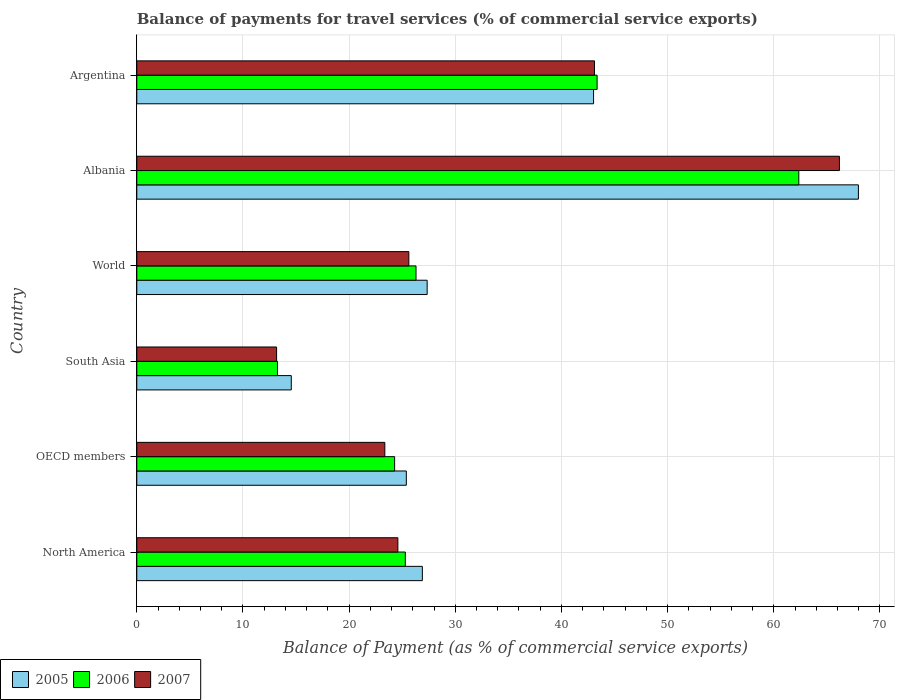Are the number of bars on each tick of the Y-axis equal?
Your response must be concise. Yes. How many bars are there on the 5th tick from the top?
Ensure brevity in your answer.  3. How many bars are there on the 6th tick from the bottom?
Provide a short and direct response. 3. What is the balance of payments for travel services in 2005 in OECD members?
Offer a terse response. 25.39. Across all countries, what is the maximum balance of payments for travel services in 2005?
Offer a very short reply. 67.97. Across all countries, what is the minimum balance of payments for travel services in 2007?
Offer a very short reply. 13.17. In which country was the balance of payments for travel services in 2007 maximum?
Keep it short and to the point. Albania. In which country was the balance of payments for travel services in 2006 minimum?
Give a very brief answer. South Asia. What is the total balance of payments for travel services in 2006 in the graph?
Your response must be concise. 194.85. What is the difference between the balance of payments for travel services in 2006 in South Asia and that in World?
Provide a short and direct response. -13.05. What is the difference between the balance of payments for travel services in 2006 in Argentina and the balance of payments for travel services in 2005 in Albania?
Give a very brief answer. -24.62. What is the average balance of payments for travel services in 2007 per country?
Offer a very short reply. 32.67. What is the difference between the balance of payments for travel services in 2006 and balance of payments for travel services in 2007 in OECD members?
Give a very brief answer. 0.92. What is the ratio of the balance of payments for travel services in 2005 in North America to that in OECD members?
Your response must be concise. 1.06. Is the difference between the balance of payments for travel services in 2006 in Albania and OECD members greater than the difference between the balance of payments for travel services in 2007 in Albania and OECD members?
Make the answer very short. No. What is the difference between the highest and the second highest balance of payments for travel services in 2005?
Ensure brevity in your answer.  24.95. What is the difference between the highest and the lowest balance of payments for travel services in 2007?
Offer a very short reply. 53.02. In how many countries, is the balance of payments for travel services in 2005 greater than the average balance of payments for travel services in 2005 taken over all countries?
Give a very brief answer. 2. Is the sum of the balance of payments for travel services in 2006 in Argentina and South Asia greater than the maximum balance of payments for travel services in 2005 across all countries?
Offer a very short reply. No. What does the 2nd bar from the bottom in Argentina represents?
Offer a very short reply. 2006. Is it the case that in every country, the sum of the balance of payments for travel services in 2006 and balance of payments for travel services in 2005 is greater than the balance of payments for travel services in 2007?
Provide a succinct answer. Yes. What is the difference between two consecutive major ticks on the X-axis?
Give a very brief answer. 10. Are the values on the major ticks of X-axis written in scientific E-notation?
Your answer should be very brief. No. Does the graph contain any zero values?
Offer a terse response. No. Where does the legend appear in the graph?
Provide a succinct answer. Bottom left. How many legend labels are there?
Your answer should be compact. 3. What is the title of the graph?
Offer a very short reply. Balance of payments for travel services (% of commercial service exports). What is the label or title of the X-axis?
Ensure brevity in your answer.  Balance of Payment (as % of commercial service exports). What is the label or title of the Y-axis?
Provide a short and direct response. Country. What is the Balance of Payment (as % of commercial service exports) of 2005 in North America?
Your answer should be compact. 26.9. What is the Balance of Payment (as % of commercial service exports) in 2006 in North America?
Provide a short and direct response. 25.3. What is the Balance of Payment (as % of commercial service exports) of 2007 in North America?
Your response must be concise. 24.59. What is the Balance of Payment (as % of commercial service exports) in 2005 in OECD members?
Keep it short and to the point. 25.39. What is the Balance of Payment (as % of commercial service exports) of 2006 in OECD members?
Your response must be concise. 24.29. What is the Balance of Payment (as % of commercial service exports) of 2007 in OECD members?
Your response must be concise. 23.36. What is the Balance of Payment (as % of commercial service exports) in 2005 in South Asia?
Offer a very short reply. 14.55. What is the Balance of Payment (as % of commercial service exports) of 2006 in South Asia?
Provide a short and direct response. 13.25. What is the Balance of Payment (as % of commercial service exports) of 2007 in South Asia?
Provide a short and direct response. 13.17. What is the Balance of Payment (as % of commercial service exports) in 2005 in World?
Your answer should be compact. 27.35. What is the Balance of Payment (as % of commercial service exports) of 2006 in World?
Make the answer very short. 26.3. What is the Balance of Payment (as % of commercial service exports) in 2007 in World?
Make the answer very short. 25.63. What is the Balance of Payment (as % of commercial service exports) in 2005 in Albania?
Your response must be concise. 67.97. What is the Balance of Payment (as % of commercial service exports) of 2006 in Albania?
Make the answer very short. 62.36. What is the Balance of Payment (as % of commercial service exports) in 2007 in Albania?
Provide a short and direct response. 66.18. What is the Balance of Payment (as % of commercial service exports) in 2005 in Argentina?
Provide a short and direct response. 43.03. What is the Balance of Payment (as % of commercial service exports) in 2006 in Argentina?
Ensure brevity in your answer.  43.36. What is the Balance of Payment (as % of commercial service exports) in 2007 in Argentina?
Offer a very short reply. 43.11. Across all countries, what is the maximum Balance of Payment (as % of commercial service exports) in 2005?
Provide a succinct answer. 67.97. Across all countries, what is the maximum Balance of Payment (as % of commercial service exports) in 2006?
Ensure brevity in your answer.  62.36. Across all countries, what is the maximum Balance of Payment (as % of commercial service exports) in 2007?
Your answer should be very brief. 66.18. Across all countries, what is the minimum Balance of Payment (as % of commercial service exports) in 2005?
Ensure brevity in your answer.  14.55. Across all countries, what is the minimum Balance of Payment (as % of commercial service exports) in 2006?
Provide a short and direct response. 13.25. Across all countries, what is the minimum Balance of Payment (as % of commercial service exports) of 2007?
Your answer should be compact. 13.17. What is the total Balance of Payment (as % of commercial service exports) in 2005 in the graph?
Give a very brief answer. 205.19. What is the total Balance of Payment (as % of commercial service exports) of 2006 in the graph?
Keep it short and to the point. 194.85. What is the total Balance of Payment (as % of commercial service exports) in 2007 in the graph?
Offer a very short reply. 196.05. What is the difference between the Balance of Payment (as % of commercial service exports) of 2005 in North America and that in OECD members?
Your answer should be compact. 1.51. What is the difference between the Balance of Payment (as % of commercial service exports) in 2006 in North America and that in OECD members?
Ensure brevity in your answer.  1.01. What is the difference between the Balance of Payment (as % of commercial service exports) of 2007 in North America and that in OECD members?
Give a very brief answer. 1.23. What is the difference between the Balance of Payment (as % of commercial service exports) in 2005 in North America and that in South Asia?
Your response must be concise. 12.35. What is the difference between the Balance of Payment (as % of commercial service exports) of 2006 in North America and that in South Asia?
Offer a very short reply. 12.04. What is the difference between the Balance of Payment (as % of commercial service exports) of 2007 in North America and that in South Asia?
Your answer should be compact. 11.42. What is the difference between the Balance of Payment (as % of commercial service exports) in 2005 in North America and that in World?
Provide a short and direct response. -0.45. What is the difference between the Balance of Payment (as % of commercial service exports) of 2006 in North America and that in World?
Provide a short and direct response. -1.01. What is the difference between the Balance of Payment (as % of commercial service exports) in 2007 in North America and that in World?
Your response must be concise. -1.04. What is the difference between the Balance of Payment (as % of commercial service exports) in 2005 in North America and that in Albania?
Provide a succinct answer. -41.07. What is the difference between the Balance of Payment (as % of commercial service exports) of 2006 in North America and that in Albania?
Your answer should be compact. -37.06. What is the difference between the Balance of Payment (as % of commercial service exports) in 2007 in North America and that in Albania?
Make the answer very short. -41.59. What is the difference between the Balance of Payment (as % of commercial service exports) in 2005 in North America and that in Argentina?
Make the answer very short. -16.13. What is the difference between the Balance of Payment (as % of commercial service exports) of 2006 in North America and that in Argentina?
Give a very brief answer. -18.06. What is the difference between the Balance of Payment (as % of commercial service exports) in 2007 in North America and that in Argentina?
Provide a short and direct response. -18.52. What is the difference between the Balance of Payment (as % of commercial service exports) in 2005 in OECD members and that in South Asia?
Your answer should be compact. 10.84. What is the difference between the Balance of Payment (as % of commercial service exports) of 2006 in OECD members and that in South Asia?
Offer a very short reply. 11.04. What is the difference between the Balance of Payment (as % of commercial service exports) of 2007 in OECD members and that in South Asia?
Keep it short and to the point. 10.2. What is the difference between the Balance of Payment (as % of commercial service exports) of 2005 in OECD members and that in World?
Provide a succinct answer. -1.96. What is the difference between the Balance of Payment (as % of commercial service exports) in 2006 in OECD members and that in World?
Make the answer very short. -2.01. What is the difference between the Balance of Payment (as % of commercial service exports) of 2007 in OECD members and that in World?
Your answer should be compact. -2.26. What is the difference between the Balance of Payment (as % of commercial service exports) of 2005 in OECD members and that in Albania?
Keep it short and to the point. -42.58. What is the difference between the Balance of Payment (as % of commercial service exports) in 2006 in OECD members and that in Albania?
Give a very brief answer. -38.07. What is the difference between the Balance of Payment (as % of commercial service exports) of 2007 in OECD members and that in Albania?
Your answer should be very brief. -42.82. What is the difference between the Balance of Payment (as % of commercial service exports) of 2005 in OECD members and that in Argentina?
Provide a short and direct response. -17.64. What is the difference between the Balance of Payment (as % of commercial service exports) of 2006 in OECD members and that in Argentina?
Your response must be concise. -19.07. What is the difference between the Balance of Payment (as % of commercial service exports) of 2007 in OECD members and that in Argentina?
Your answer should be compact. -19.75. What is the difference between the Balance of Payment (as % of commercial service exports) of 2005 in South Asia and that in World?
Your response must be concise. -12.8. What is the difference between the Balance of Payment (as % of commercial service exports) of 2006 in South Asia and that in World?
Offer a very short reply. -13.05. What is the difference between the Balance of Payment (as % of commercial service exports) in 2007 in South Asia and that in World?
Your answer should be compact. -12.46. What is the difference between the Balance of Payment (as % of commercial service exports) of 2005 in South Asia and that in Albania?
Your answer should be compact. -53.42. What is the difference between the Balance of Payment (as % of commercial service exports) in 2006 in South Asia and that in Albania?
Offer a terse response. -49.11. What is the difference between the Balance of Payment (as % of commercial service exports) in 2007 in South Asia and that in Albania?
Ensure brevity in your answer.  -53.02. What is the difference between the Balance of Payment (as % of commercial service exports) in 2005 in South Asia and that in Argentina?
Your answer should be compact. -28.47. What is the difference between the Balance of Payment (as % of commercial service exports) in 2006 in South Asia and that in Argentina?
Provide a succinct answer. -30.11. What is the difference between the Balance of Payment (as % of commercial service exports) in 2007 in South Asia and that in Argentina?
Your answer should be compact. -29.94. What is the difference between the Balance of Payment (as % of commercial service exports) of 2005 in World and that in Albania?
Provide a short and direct response. -40.62. What is the difference between the Balance of Payment (as % of commercial service exports) in 2006 in World and that in Albania?
Make the answer very short. -36.06. What is the difference between the Balance of Payment (as % of commercial service exports) in 2007 in World and that in Albania?
Give a very brief answer. -40.56. What is the difference between the Balance of Payment (as % of commercial service exports) of 2005 in World and that in Argentina?
Ensure brevity in your answer.  -15.68. What is the difference between the Balance of Payment (as % of commercial service exports) in 2006 in World and that in Argentina?
Make the answer very short. -17.06. What is the difference between the Balance of Payment (as % of commercial service exports) of 2007 in World and that in Argentina?
Offer a very short reply. -17.49. What is the difference between the Balance of Payment (as % of commercial service exports) in 2005 in Albania and that in Argentina?
Give a very brief answer. 24.95. What is the difference between the Balance of Payment (as % of commercial service exports) in 2006 in Albania and that in Argentina?
Provide a succinct answer. 19. What is the difference between the Balance of Payment (as % of commercial service exports) of 2007 in Albania and that in Argentina?
Provide a succinct answer. 23.07. What is the difference between the Balance of Payment (as % of commercial service exports) in 2005 in North America and the Balance of Payment (as % of commercial service exports) in 2006 in OECD members?
Your answer should be very brief. 2.61. What is the difference between the Balance of Payment (as % of commercial service exports) of 2005 in North America and the Balance of Payment (as % of commercial service exports) of 2007 in OECD members?
Provide a succinct answer. 3.53. What is the difference between the Balance of Payment (as % of commercial service exports) in 2006 in North America and the Balance of Payment (as % of commercial service exports) in 2007 in OECD members?
Ensure brevity in your answer.  1.93. What is the difference between the Balance of Payment (as % of commercial service exports) of 2005 in North America and the Balance of Payment (as % of commercial service exports) of 2006 in South Asia?
Make the answer very short. 13.65. What is the difference between the Balance of Payment (as % of commercial service exports) of 2005 in North America and the Balance of Payment (as % of commercial service exports) of 2007 in South Asia?
Your answer should be very brief. 13.73. What is the difference between the Balance of Payment (as % of commercial service exports) in 2006 in North America and the Balance of Payment (as % of commercial service exports) in 2007 in South Asia?
Give a very brief answer. 12.13. What is the difference between the Balance of Payment (as % of commercial service exports) in 2005 in North America and the Balance of Payment (as % of commercial service exports) in 2006 in World?
Ensure brevity in your answer.  0.6. What is the difference between the Balance of Payment (as % of commercial service exports) of 2005 in North America and the Balance of Payment (as % of commercial service exports) of 2007 in World?
Your answer should be compact. 1.27. What is the difference between the Balance of Payment (as % of commercial service exports) of 2006 in North America and the Balance of Payment (as % of commercial service exports) of 2007 in World?
Ensure brevity in your answer.  -0.33. What is the difference between the Balance of Payment (as % of commercial service exports) in 2005 in North America and the Balance of Payment (as % of commercial service exports) in 2006 in Albania?
Make the answer very short. -35.46. What is the difference between the Balance of Payment (as % of commercial service exports) in 2005 in North America and the Balance of Payment (as % of commercial service exports) in 2007 in Albania?
Your response must be concise. -39.29. What is the difference between the Balance of Payment (as % of commercial service exports) in 2006 in North America and the Balance of Payment (as % of commercial service exports) in 2007 in Albania?
Give a very brief answer. -40.89. What is the difference between the Balance of Payment (as % of commercial service exports) of 2005 in North America and the Balance of Payment (as % of commercial service exports) of 2006 in Argentina?
Ensure brevity in your answer.  -16.46. What is the difference between the Balance of Payment (as % of commercial service exports) of 2005 in North America and the Balance of Payment (as % of commercial service exports) of 2007 in Argentina?
Provide a short and direct response. -16.21. What is the difference between the Balance of Payment (as % of commercial service exports) in 2006 in North America and the Balance of Payment (as % of commercial service exports) in 2007 in Argentina?
Offer a terse response. -17.82. What is the difference between the Balance of Payment (as % of commercial service exports) in 2005 in OECD members and the Balance of Payment (as % of commercial service exports) in 2006 in South Asia?
Your answer should be compact. 12.14. What is the difference between the Balance of Payment (as % of commercial service exports) of 2005 in OECD members and the Balance of Payment (as % of commercial service exports) of 2007 in South Asia?
Keep it short and to the point. 12.22. What is the difference between the Balance of Payment (as % of commercial service exports) in 2006 in OECD members and the Balance of Payment (as % of commercial service exports) in 2007 in South Asia?
Your response must be concise. 11.12. What is the difference between the Balance of Payment (as % of commercial service exports) of 2005 in OECD members and the Balance of Payment (as % of commercial service exports) of 2006 in World?
Ensure brevity in your answer.  -0.91. What is the difference between the Balance of Payment (as % of commercial service exports) of 2005 in OECD members and the Balance of Payment (as % of commercial service exports) of 2007 in World?
Ensure brevity in your answer.  -0.24. What is the difference between the Balance of Payment (as % of commercial service exports) in 2006 in OECD members and the Balance of Payment (as % of commercial service exports) in 2007 in World?
Your response must be concise. -1.34. What is the difference between the Balance of Payment (as % of commercial service exports) of 2005 in OECD members and the Balance of Payment (as % of commercial service exports) of 2006 in Albania?
Your answer should be very brief. -36.97. What is the difference between the Balance of Payment (as % of commercial service exports) in 2005 in OECD members and the Balance of Payment (as % of commercial service exports) in 2007 in Albania?
Provide a succinct answer. -40.8. What is the difference between the Balance of Payment (as % of commercial service exports) in 2006 in OECD members and the Balance of Payment (as % of commercial service exports) in 2007 in Albania?
Your response must be concise. -41.9. What is the difference between the Balance of Payment (as % of commercial service exports) in 2005 in OECD members and the Balance of Payment (as % of commercial service exports) in 2006 in Argentina?
Your response must be concise. -17.97. What is the difference between the Balance of Payment (as % of commercial service exports) of 2005 in OECD members and the Balance of Payment (as % of commercial service exports) of 2007 in Argentina?
Offer a very short reply. -17.72. What is the difference between the Balance of Payment (as % of commercial service exports) in 2006 in OECD members and the Balance of Payment (as % of commercial service exports) in 2007 in Argentina?
Your answer should be very brief. -18.83. What is the difference between the Balance of Payment (as % of commercial service exports) in 2005 in South Asia and the Balance of Payment (as % of commercial service exports) in 2006 in World?
Provide a short and direct response. -11.75. What is the difference between the Balance of Payment (as % of commercial service exports) of 2005 in South Asia and the Balance of Payment (as % of commercial service exports) of 2007 in World?
Give a very brief answer. -11.07. What is the difference between the Balance of Payment (as % of commercial service exports) in 2006 in South Asia and the Balance of Payment (as % of commercial service exports) in 2007 in World?
Keep it short and to the point. -12.38. What is the difference between the Balance of Payment (as % of commercial service exports) in 2005 in South Asia and the Balance of Payment (as % of commercial service exports) in 2006 in Albania?
Keep it short and to the point. -47.81. What is the difference between the Balance of Payment (as % of commercial service exports) of 2005 in South Asia and the Balance of Payment (as % of commercial service exports) of 2007 in Albania?
Keep it short and to the point. -51.63. What is the difference between the Balance of Payment (as % of commercial service exports) in 2006 in South Asia and the Balance of Payment (as % of commercial service exports) in 2007 in Albania?
Your response must be concise. -52.93. What is the difference between the Balance of Payment (as % of commercial service exports) of 2005 in South Asia and the Balance of Payment (as % of commercial service exports) of 2006 in Argentina?
Provide a succinct answer. -28.81. What is the difference between the Balance of Payment (as % of commercial service exports) of 2005 in South Asia and the Balance of Payment (as % of commercial service exports) of 2007 in Argentina?
Ensure brevity in your answer.  -28.56. What is the difference between the Balance of Payment (as % of commercial service exports) in 2006 in South Asia and the Balance of Payment (as % of commercial service exports) in 2007 in Argentina?
Keep it short and to the point. -29.86. What is the difference between the Balance of Payment (as % of commercial service exports) of 2005 in World and the Balance of Payment (as % of commercial service exports) of 2006 in Albania?
Your response must be concise. -35.01. What is the difference between the Balance of Payment (as % of commercial service exports) in 2005 in World and the Balance of Payment (as % of commercial service exports) in 2007 in Albania?
Your answer should be very brief. -38.83. What is the difference between the Balance of Payment (as % of commercial service exports) of 2006 in World and the Balance of Payment (as % of commercial service exports) of 2007 in Albania?
Keep it short and to the point. -39.88. What is the difference between the Balance of Payment (as % of commercial service exports) of 2005 in World and the Balance of Payment (as % of commercial service exports) of 2006 in Argentina?
Make the answer very short. -16.01. What is the difference between the Balance of Payment (as % of commercial service exports) in 2005 in World and the Balance of Payment (as % of commercial service exports) in 2007 in Argentina?
Offer a very short reply. -15.76. What is the difference between the Balance of Payment (as % of commercial service exports) in 2006 in World and the Balance of Payment (as % of commercial service exports) in 2007 in Argentina?
Ensure brevity in your answer.  -16.81. What is the difference between the Balance of Payment (as % of commercial service exports) in 2005 in Albania and the Balance of Payment (as % of commercial service exports) in 2006 in Argentina?
Offer a very short reply. 24.62. What is the difference between the Balance of Payment (as % of commercial service exports) of 2005 in Albania and the Balance of Payment (as % of commercial service exports) of 2007 in Argentina?
Keep it short and to the point. 24.86. What is the difference between the Balance of Payment (as % of commercial service exports) of 2006 in Albania and the Balance of Payment (as % of commercial service exports) of 2007 in Argentina?
Offer a terse response. 19.25. What is the average Balance of Payment (as % of commercial service exports) of 2005 per country?
Provide a succinct answer. 34.2. What is the average Balance of Payment (as % of commercial service exports) of 2006 per country?
Your answer should be compact. 32.48. What is the average Balance of Payment (as % of commercial service exports) of 2007 per country?
Keep it short and to the point. 32.67. What is the difference between the Balance of Payment (as % of commercial service exports) in 2005 and Balance of Payment (as % of commercial service exports) in 2006 in North America?
Keep it short and to the point. 1.6. What is the difference between the Balance of Payment (as % of commercial service exports) of 2005 and Balance of Payment (as % of commercial service exports) of 2007 in North America?
Provide a short and direct response. 2.31. What is the difference between the Balance of Payment (as % of commercial service exports) in 2006 and Balance of Payment (as % of commercial service exports) in 2007 in North America?
Provide a short and direct response. 0.7. What is the difference between the Balance of Payment (as % of commercial service exports) in 2005 and Balance of Payment (as % of commercial service exports) in 2006 in OECD members?
Your answer should be very brief. 1.1. What is the difference between the Balance of Payment (as % of commercial service exports) of 2005 and Balance of Payment (as % of commercial service exports) of 2007 in OECD members?
Ensure brevity in your answer.  2.03. What is the difference between the Balance of Payment (as % of commercial service exports) in 2006 and Balance of Payment (as % of commercial service exports) in 2007 in OECD members?
Give a very brief answer. 0.92. What is the difference between the Balance of Payment (as % of commercial service exports) of 2005 and Balance of Payment (as % of commercial service exports) of 2006 in South Asia?
Provide a short and direct response. 1.3. What is the difference between the Balance of Payment (as % of commercial service exports) of 2005 and Balance of Payment (as % of commercial service exports) of 2007 in South Asia?
Provide a short and direct response. 1.38. What is the difference between the Balance of Payment (as % of commercial service exports) of 2006 and Balance of Payment (as % of commercial service exports) of 2007 in South Asia?
Your response must be concise. 0.08. What is the difference between the Balance of Payment (as % of commercial service exports) of 2005 and Balance of Payment (as % of commercial service exports) of 2006 in World?
Make the answer very short. 1.05. What is the difference between the Balance of Payment (as % of commercial service exports) of 2005 and Balance of Payment (as % of commercial service exports) of 2007 in World?
Make the answer very short. 1.72. What is the difference between the Balance of Payment (as % of commercial service exports) of 2006 and Balance of Payment (as % of commercial service exports) of 2007 in World?
Your answer should be very brief. 0.68. What is the difference between the Balance of Payment (as % of commercial service exports) in 2005 and Balance of Payment (as % of commercial service exports) in 2006 in Albania?
Provide a short and direct response. 5.62. What is the difference between the Balance of Payment (as % of commercial service exports) in 2005 and Balance of Payment (as % of commercial service exports) in 2007 in Albania?
Provide a succinct answer. 1.79. What is the difference between the Balance of Payment (as % of commercial service exports) in 2006 and Balance of Payment (as % of commercial service exports) in 2007 in Albania?
Offer a terse response. -3.83. What is the difference between the Balance of Payment (as % of commercial service exports) of 2005 and Balance of Payment (as % of commercial service exports) of 2006 in Argentina?
Provide a short and direct response. -0.33. What is the difference between the Balance of Payment (as % of commercial service exports) in 2005 and Balance of Payment (as % of commercial service exports) in 2007 in Argentina?
Your response must be concise. -0.09. What is the difference between the Balance of Payment (as % of commercial service exports) of 2006 and Balance of Payment (as % of commercial service exports) of 2007 in Argentina?
Give a very brief answer. 0.25. What is the ratio of the Balance of Payment (as % of commercial service exports) of 2005 in North America to that in OECD members?
Keep it short and to the point. 1.06. What is the ratio of the Balance of Payment (as % of commercial service exports) in 2006 in North America to that in OECD members?
Make the answer very short. 1.04. What is the ratio of the Balance of Payment (as % of commercial service exports) in 2007 in North America to that in OECD members?
Give a very brief answer. 1.05. What is the ratio of the Balance of Payment (as % of commercial service exports) in 2005 in North America to that in South Asia?
Your answer should be very brief. 1.85. What is the ratio of the Balance of Payment (as % of commercial service exports) in 2006 in North America to that in South Asia?
Provide a short and direct response. 1.91. What is the ratio of the Balance of Payment (as % of commercial service exports) in 2007 in North America to that in South Asia?
Make the answer very short. 1.87. What is the ratio of the Balance of Payment (as % of commercial service exports) in 2005 in North America to that in World?
Make the answer very short. 0.98. What is the ratio of the Balance of Payment (as % of commercial service exports) of 2006 in North America to that in World?
Ensure brevity in your answer.  0.96. What is the ratio of the Balance of Payment (as % of commercial service exports) in 2007 in North America to that in World?
Provide a succinct answer. 0.96. What is the ratio of the Balance of Payment (as % of commercial service exports) in 2005 in North America to that in Albania?
Provide a short and direct response. 0.4. What is the ratio of the Balance of Payment (as % of commercial service exports) in 2006 in North America to that in Albania?
Offer a very short reply. 0.41. What is the ratio of the Balance of Payment (as % of commercial service exports) of 2007 in North America to that in Albania?
Provide a succinct answer. 0.37. What is the ratio of the Balance of Payment (as % of commercial service exports) of 2005 in North America to that in Argentina?
Offer a very short reply. 0.63. What is the ratio of the Balance of Payment (as % of commercial service exports) in 2006 in North America to that in Argentina?
Provide a succinct answer. 0.58. What is the ratio of the Balance of Payment (as % of commercial service exports) in 2007 in North America to that in Argentina?
Ensure brevity in your answer.  0.57. What is the ratio of the Balance of Payment (as % of commercial service exports) of 2005 in OECD members to that in South Asia?
Your response must be concise. 1.74. What is the ratio of the Balance of Payment (as % of commercial service exports) in 2006 in OECD members to that in South Asia?
Offer a terse response. 1.83. What is the ratio of the Balance of Payment (as % of commercial service exports) of 2007 in OECD members to that in South Asia?
Offer a terse response. 1.77. What is the ratio of the Balance of Payment (as % of commercial service exports) of 2005 in OECD members to that in World?
Ensure brevity in your answer.  0.93. What is the ratio of the Balance of Payment (as % of commercial service exports) in 2006 in OECD members to that in World?
Keep it short and to the point. 0.92. What is the ratio of the Balance of Payment (as % of commercial service exports) of 2007 in OECD members to that in World?
Your response must be concise. 0.91. What is the ratio of the Balance of Payment (as % of commercial service exports) of 2005 in OECD members to that in Albania?
Offer a very short reply. 0.37. What is the ratio of the Balance of Payment (as % of commercial service exports) in 2006 in OECD members to that in Albania?
Offer a terse response. 0.39. What is the ratio of the Balance of Payment (as % of commercial service exports) in 2007 in OECD members to that in Albania?
Your answer should be compact. 0.35. What is the ratio of the Balance of Payment (as % of commercial service exports) in 2005 in OECD members to that in Argentina?
Provide a succinct answer. 0.59. What is the ratio of the Balance of Payment (as % of commercial service exports) of 2006 in OECD members to that in Argentina?
Your answer should be compact. 0.56. What is the ratio of the Balance of Payment (as % of commercial service exports) of 2007 in OECD members to that in Argentina?
Your response must be concise. 0.54. What is the ratio of the Balance of Payment (as % of commercial service exports) in 2005 in South Asia to that in World?
Ensure brevity in your answer.  0.53. What is the ratio of the Balance of Payment (as % of commercial service exports) in 2006 in South Asia to that in World?
Your response must be concise. 0.5. What is the ratio of the Balance of Payment (as % of commercial service exports) of 2007 in South Asia to that in World?
Your response must be concise. 0.51. What is the ratio of the Balance of Payment (as % of commercial service exports) of 2005 in South Asia to that in Albania?
Your response must be concise. 0.21. What is the ratio of the Balance of Payment (as % of commercial service exports) of 2006 in South Asia to that in Albania?
Your response must be concise. 0.21. What is the ratio of the Balance of Payment (as % of commercial service exports) in 2007 in South Asia to that in Albania?
Offer a very short reply. 0.2. What is the ratio of the Balance of Payment (as % of commercial service exports) of 2005 in South Asia to that in Argentina?
Your response must be concise. 0.34. What is the ratio of the Balance of Payment (as % of commercial service exports) in 2006 in South Asia to that in Argentina?
Provide a short and direct response. 0.31. What is the ratio of the Balance of Payment (as % of commercial service exports) in 2007 in South Asia to that in Argentina?
Give a very brief answer. 0.31. What is the ratio of the Balance of Payment (as % of commercial service exports) in 2005 in World to that in Albania?
Provide a succinct answer. 0.4. What is the ratio of the Balance of Payment (as % of commercial service exports) of 2006 in World to that in Albania?
Provide a short and direct response. 0.42. What is the ratio of the Balance of Payment (as % of commercial service exports) in 2007 in World to that in Albania?
Provide a succinct answer. 0.39. What is the ratio of the Balance of Payment (as % of commercial service exports) in 2005 in World to that in Argentina?
Offer a terse response. 0.64. What is the ratio of the Balance of Payment (as % of commercial service exports) of 2006 in World to that in Argentina?
Offer a very short reply. 0.61. What is the ratio of the Balance of Payment (as % of commercial service exports) in 2007 in World to that in Argentina?
Provide a short and direct response. 0.59. What is the ratio of the Balance of Payment (as % of commercial service exports) in 2005 in Albania to that in Argentina?
Keep it short and to the point. 1.58. What is the ratio of the Balance of Payment (as % of commercial service exports) of 2006 in Albania to that in Argentina?
Your response must be concise. 1.44. What is the ratio of the Balance of Payment (as % of commercial service exports) in 2007 in Albania to that in Argentina?
Ensure brevity in your answer.  1.54. What is the difference between the highest and the second highest Balance of Payment (as % of commercial service exports) in 2005?
Offer a very short reply. 24.95. What is the difference between the highest and the second highest Balance of Payment (as % of commercial service exports) in 2006?
Your answer should be very brief. 19. What is the difference between the highest and the second highest Balance of Payment (as % of commercial service exports) in 2007?
Make the answer very short. 23.07. What is the difference between the highest and the lowest Balance of Payment (as % of commercial service exports) in 2005?
Provide a succinct answer. 53.42. What is the difference between the highest and the lowest Balance of Payment (as % of commercial service exports) in 2006?
Ensure brevity in your answer.  49.11. What is the difference between the highest and the lowest Balance of Payment (as % of commercial service exports) in 2007?
Offer a very short reply. 53.02. 